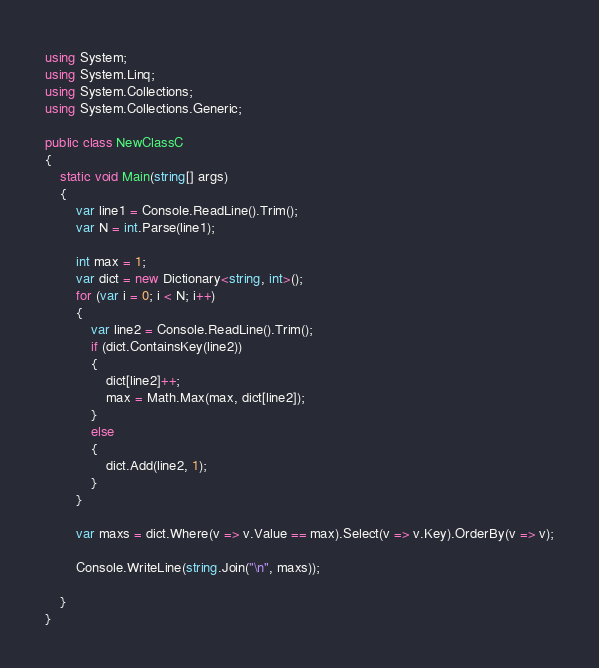Convert code to text. <code><loc_0><loc_0><loc_500><loc_500><_C#_>using System;
using System.Linq;
using System.Collections;
using System.Collections.Generic;

public class NewClassC
{
    static void Main(string[] args)
    {
        var line1 = Console.ReadLine().Trim();
        var N = int.Parse(line1);

        int max = 1;
        var dict = new Dictionary<string, int>();
        for (var i = 0; i < N; i++)
        {
            var line2 = Console.ReadLine().Trim();
            if (dict.ContainsKey(line2))
            {
                dict[line2]++;
                max = Math.Max(max, dict[line2]);
            }
            else
            {
                dict.Add(line2, 1);
            }
        }

        var maxs = dict.Where(v => v.Value == max).Select(v => v.Key).OrderBy(v => v);

        Console.WriteLine(string.Join("\n", maxs));

    }
}
</code> 